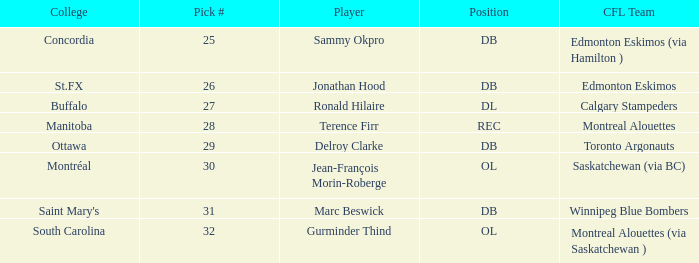Which College has a Position of ol, and a Pick # smaller than 32? Montréal. 